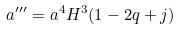<formula> <loc_0><loc_0><loc_500><loc_500>a ^ { \prime \prime \prime } = a ^ { 4 } H ^ { 3 } ( 1 - 2 q + j )</formula> 